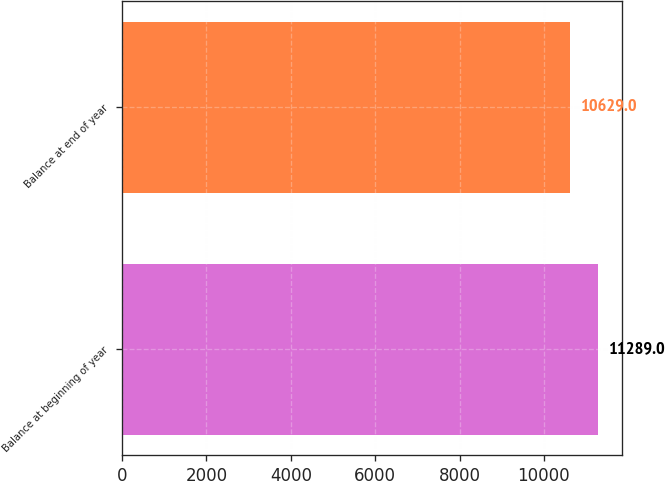Convert chart to OTSL. <chart><loc_0><loc_0><loc_500><loc_500><bar_chart><fcel>Balance at beginning of year<fcel>Balance at end of year<nl><fcel>11289<fcel>10629<nl></chart> 